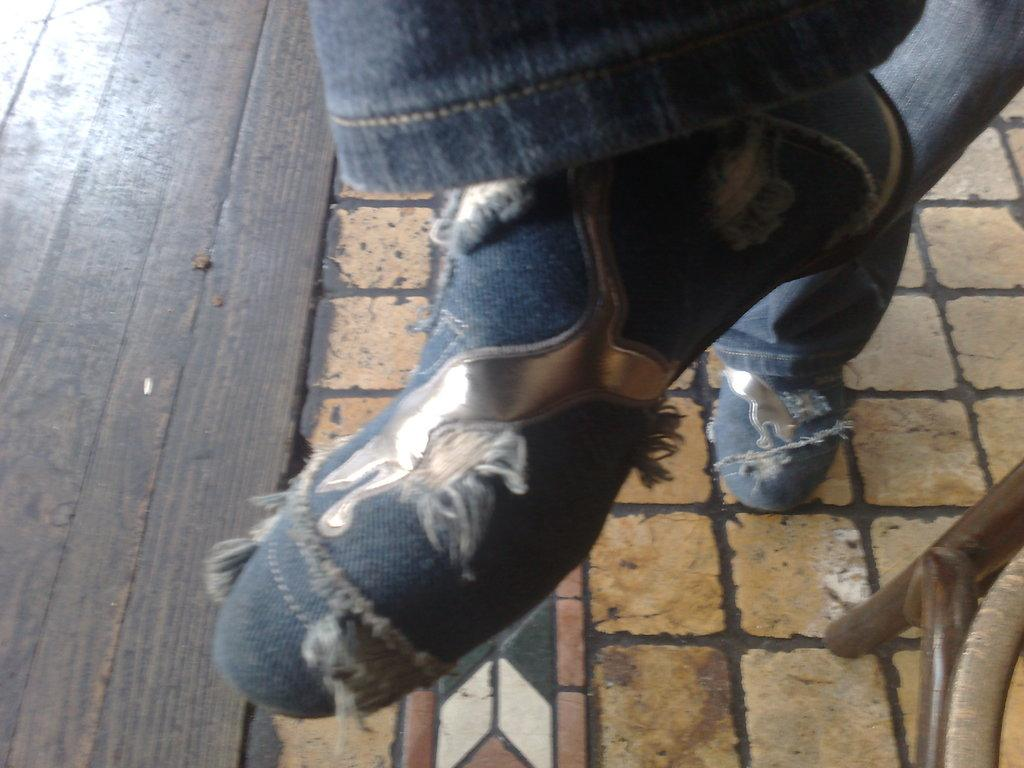Who or what is present in the image? There is a person in the image. What part of the person's body can be seen? The person's leg is visible. What is the person wearing on their leg? The person's leg is wearing shoes. What surface is the person standing on? The person is standing on the floor. What type of flooring can be seen in the background? There is wooden flooring in the background of the image. What type of rat can be seen interacting with the person in the image? There is no rat present in the image; only the person and their leg wearing shoes are visible. 